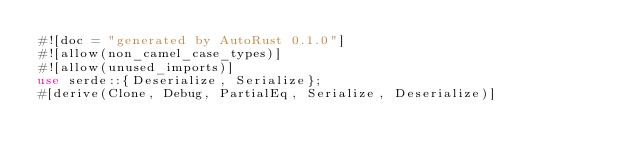Convert code to text. <code><loc_0><loc_0><loc_500><loc_500><_Rust_>#![doc = "generated by AutoRust 0.1.0"]
#![allow(non_camel_case_types)]
#![allow(unused_imports)]
use serde::{Deserialize, Serialize};
#[derive(Clone, Debug, PartialEq, Serialize, Deserialize)]</code> 